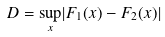<formula> <loc_0><loc_0><loc_500><loc_500>D = \underset { x } \sup | F _ { 1 } ( x ) - F _ { 2 } ( x ) |</formula> 